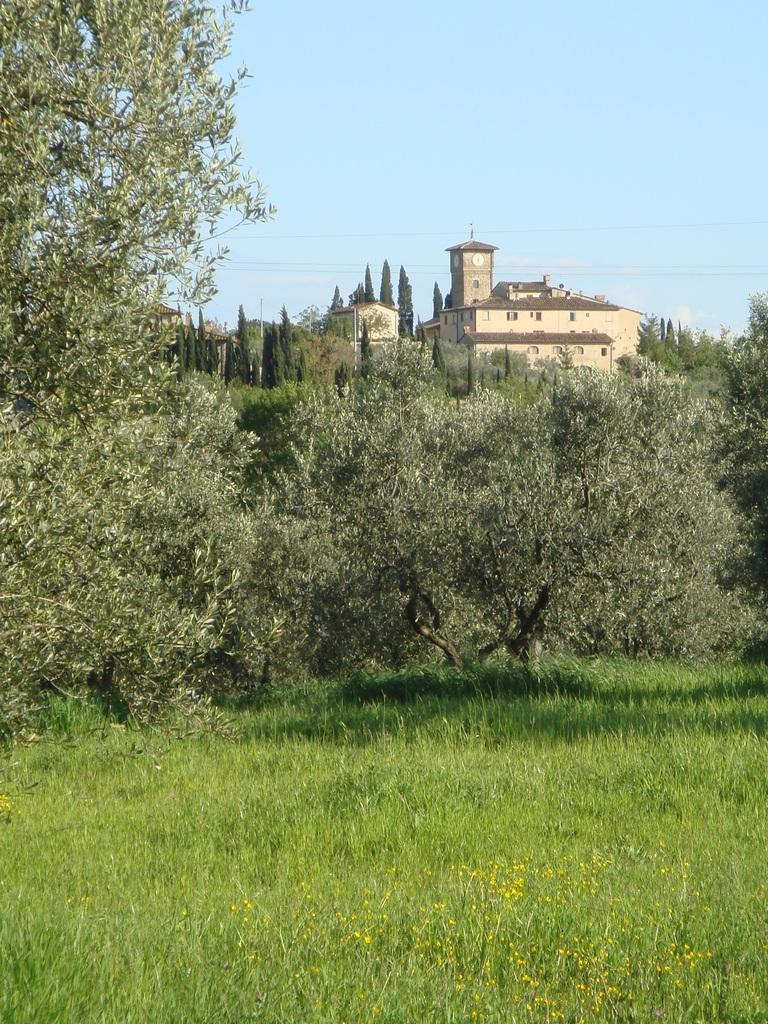What is visible in the center of the image? The sky is visible in the center of the image. What type of structures can be seen in the image? There are buildings in the image. What type of vegetation is present in the image? Trees and grass are visible in the image. What type of flora can be seen in the image? Flowers are present in the image. Are there any other objects visible in the image? Yes, there are a few other objects in the image. What type of print can be seen on the flowers in the image? There is no print on the flowers in the image; they are natural flowers. What type of badge is visible on the trees in the image? There are no badges present on the trees in the image. 